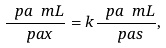Convert formula to latex. <formula><loc_0><loc_0><loc_500><loc_500>\frac { \ p a \ m L } { \ p a x } = k \frac { \ p a \ m L } { \ p a s } ,</formula> 